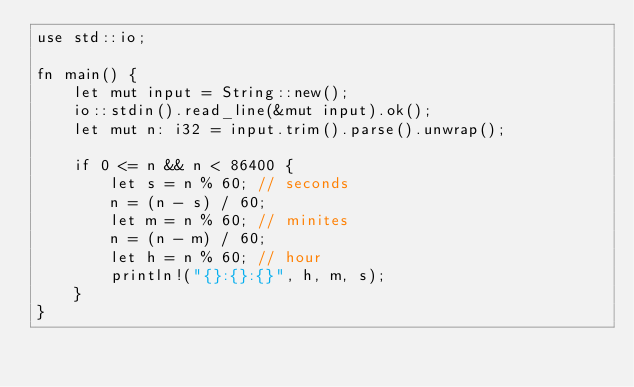<code> <loc_0><loc_0><loc_500><loc_500><_Rust_>use std::io;

fn main() {
    let mut input = String::new();
    io::stdin().read_line(&mut input).ok();
    let mut n: i32 = input.trim().parse().unwrap();

    if 0 <= n && n < 86400 {
        let s = n % 60; // seconds
        n = (n - s) / 60;
        let m = n % 60; // minites
        n = (n - m) / 60;
        let h = n % 60; // hour
        println!("{}:{}:{}", h, m, s);
    }
}
</code> 